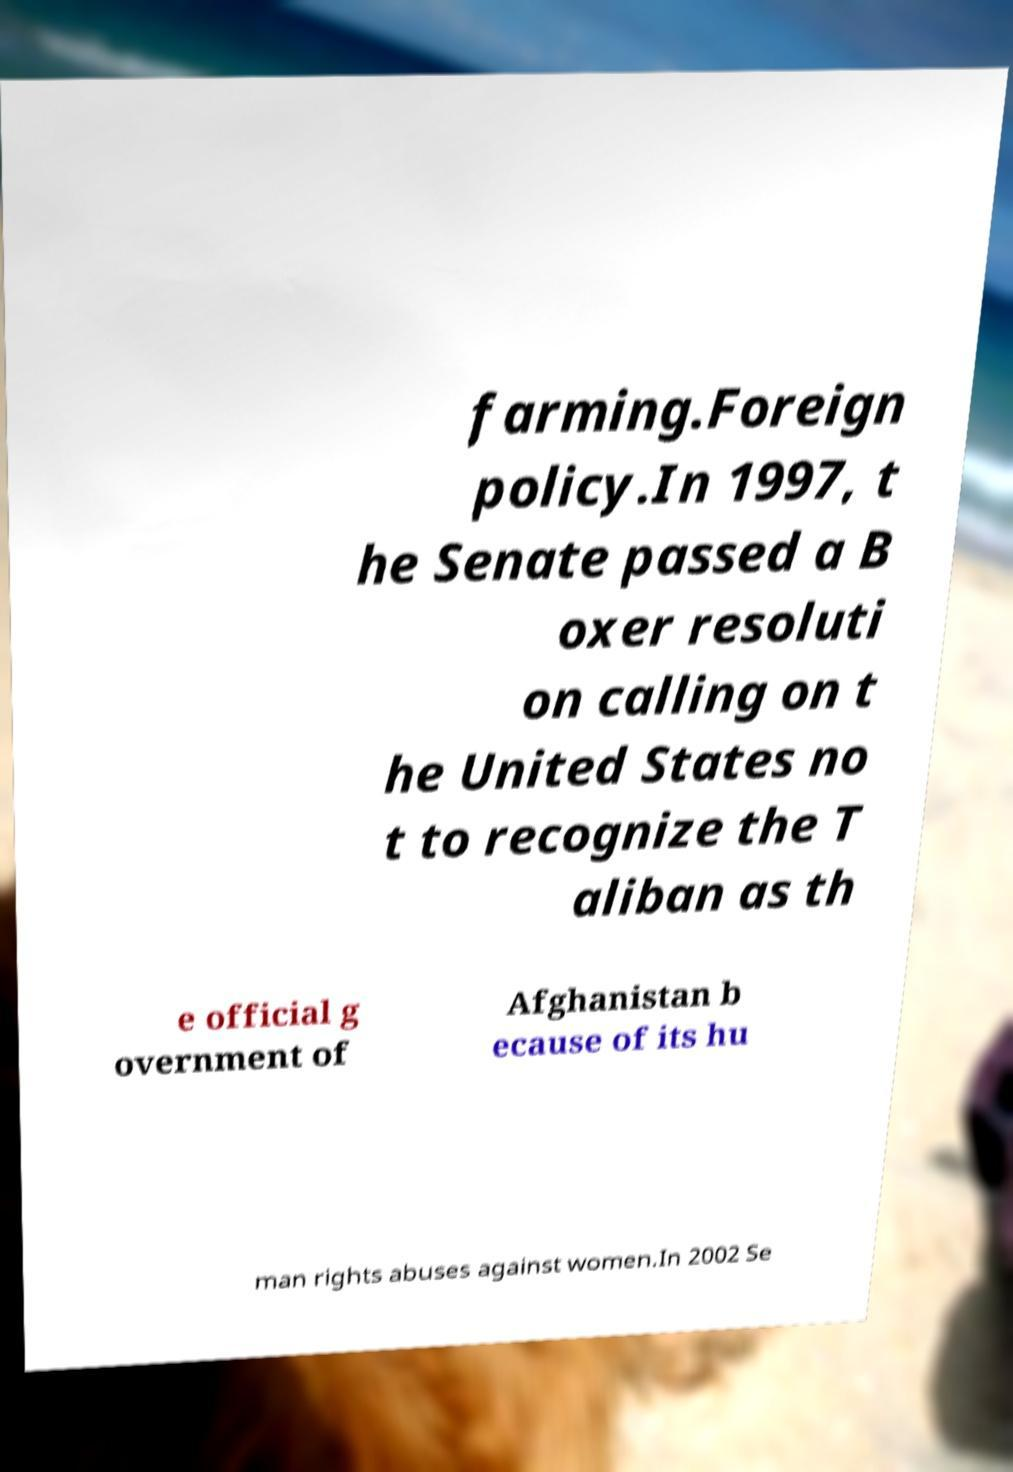Please read and relay the text visible in this image. What does it say? farming.Foreign policy.In 1997, t he Senate passed a B oxer resoluti on calling on t he United States no t to recognize the T aliban as th e official g overnment of Afghanistan b ecause of its hu man rights abuses against women.In 2002 Se 